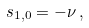Convert formula to latex. <formula><loc_0><loc_0><loc_500><loc_500>s _ { 1 , 0 } = - \nu \, ,</formula> 